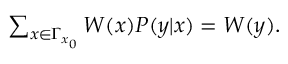Convert formula to latex. <formula><loc_0><loc_0><loc_500><loc_500>\begin{array} { r } { \sum _ { x \in \Gamma _ { x _ { 0 } } } W ( x ) P ( y | x ) = W ( y ) . } \end{array}</formula> 